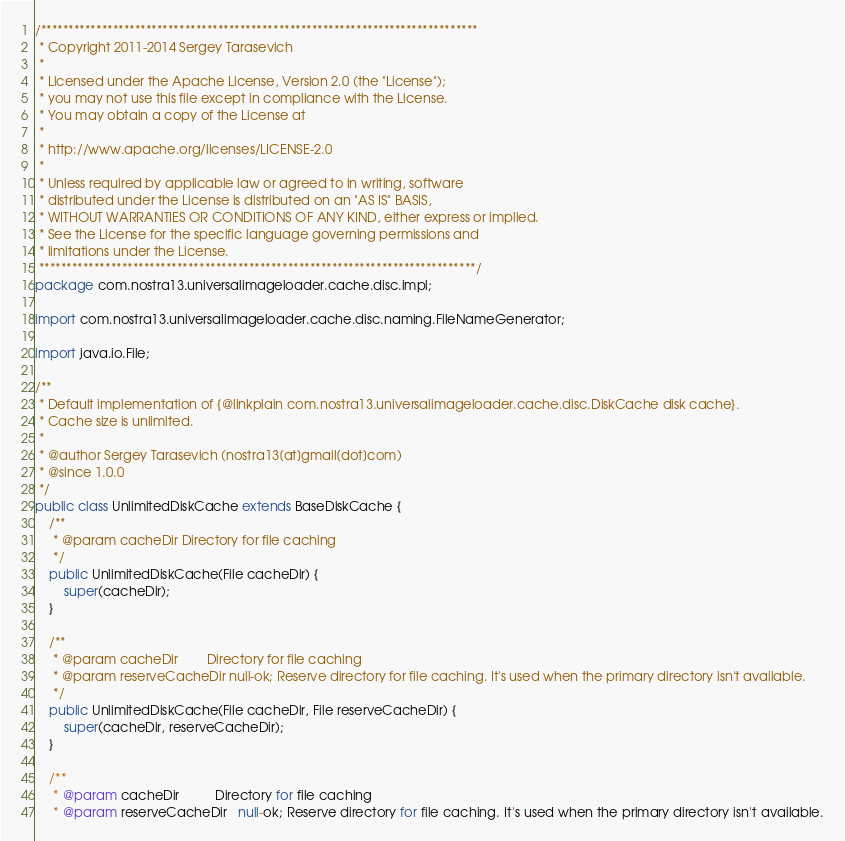<code> <loc_0><loc_0><loc_500><loc_500><_Java_>/*******************************************************************************
 * Copyright 2011-2014 Sergey Tarasevich
 *
 * Licensed under the Apache License, Version 2.0 (the "License");
 * you may not use this file except in compliance with the License.
 * You may obtain a copy of the License at
 *
 * http://www.apache.org/licenses/LICENSE-2.0
 *
 * Unless required by applicable law or agreed to in writing, software
 * distributed under the License is distributed on an "AS IS" BASIS,
 * WITHOUT WARRANTIES OR CONDITIONS OF ANY KIND, either express or implied.
 * See the License for the specific language governing permissions and
 * limitations under the License.
 *******************************************************************************/
package com.nostra13.universalimageloader.cache.disc.impl;

import com.nostra13.universalimageloader.cache.disc.naming.FileNameGenerator;

import java.io.File;

/**
 * Default implementation of {@linkplain com.nostra13.universalimageloader.cache.disc.DiskCache disk cache}.
 * Cache size is unlimited.
 *
 * @author Sergey Tarasevich (nostra13[at]gmail[dot]com)
 * @since 1.0.0
 */
public class UnlimitedDiskCache extends BaseDiskCache {
    /**
     * @param cacheDir Directory for file caching
     */
    public UnlimitedDiskCache(File cacheDir) {
        super(cacheDir);
    }

    /**
     * @param cacheDir        Directory for file caching
     * @param reserveCacheDir null-ok; Reserve directory for file caching. It's used when the primary directory isn't available.
     */
    public UnlimitedDiskCache(File cacheDir, File reserveCacheDir) {
        super(cacheDir, reserveCacheDir);
    }

    /**
     * @param cacheDir          Directory for file caching
     * @param reserveCacheDir   null-ok; Reserve directory for file caching. It's used when the primary directory isn't available.</code> 